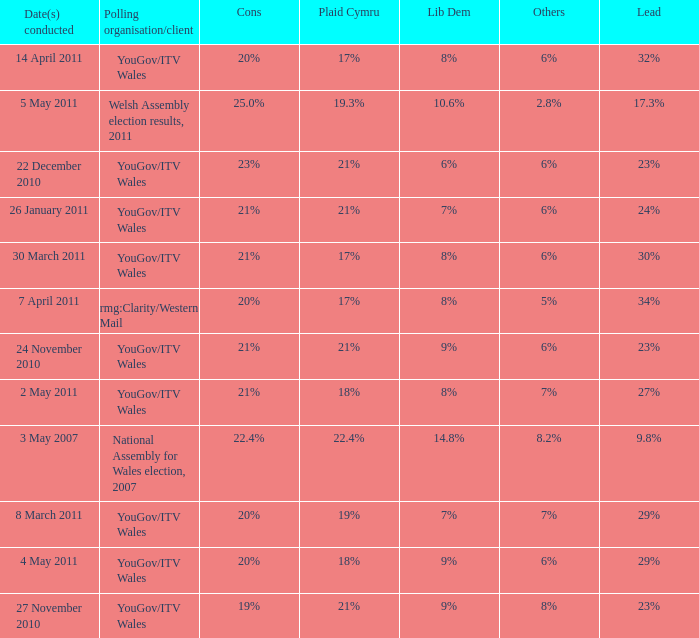I want the lead for others being 5% 34%. 